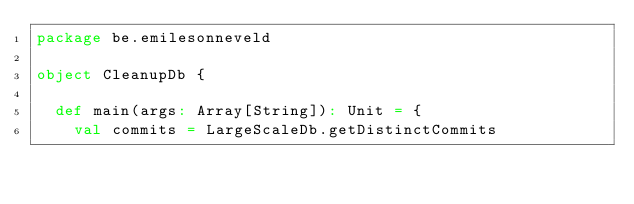<code> <loc_0><loc_0><loc_500><loc_500><_Scala_>package be.emilesonneveld

object CleanupDb {

  def main(args: Array[String]): Unit = {
    val commits = LargeScaleDb.getDistinctCommits</code> 